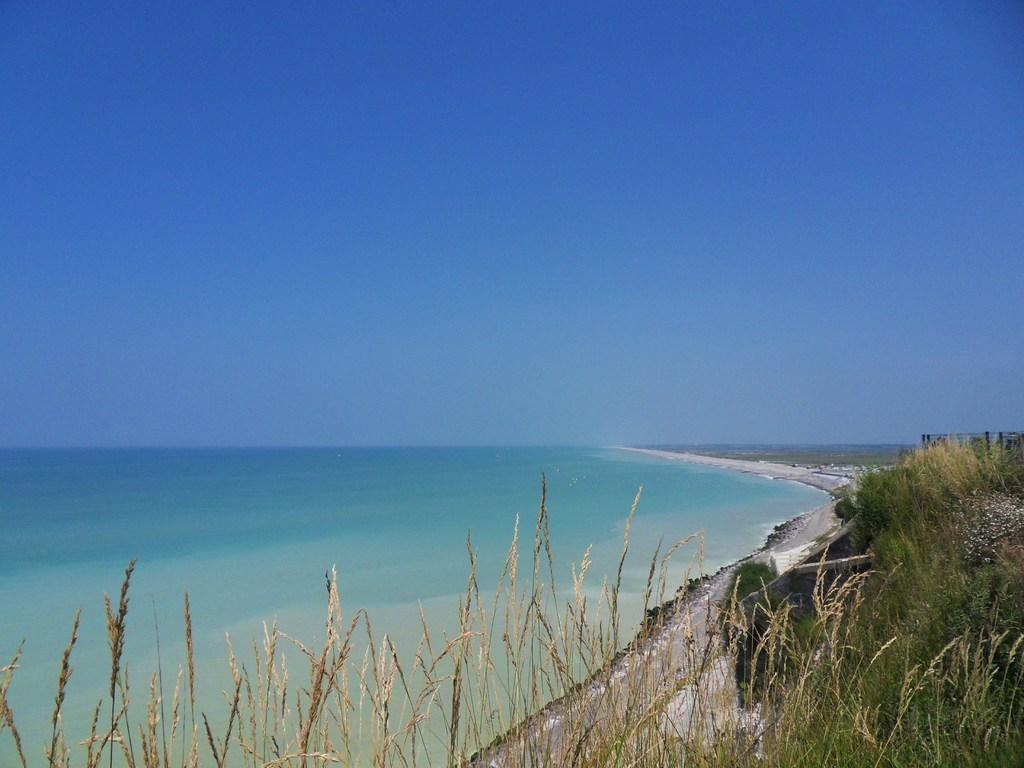Where was the image taken? The image was clicked outside. What is the main subject in the middle of the image? There is water in the middle of the image. What type of vegetation is present at the bottom of the image? There is grass at the bottom of the image. What is visible at the top of the image? The sky is visible at the top of the image. What type of trade is happening in the image? There is no trade happening in the image; it features water, grass, and the sky. Can you see a yoke in the image? There is no yoke present in the image. 